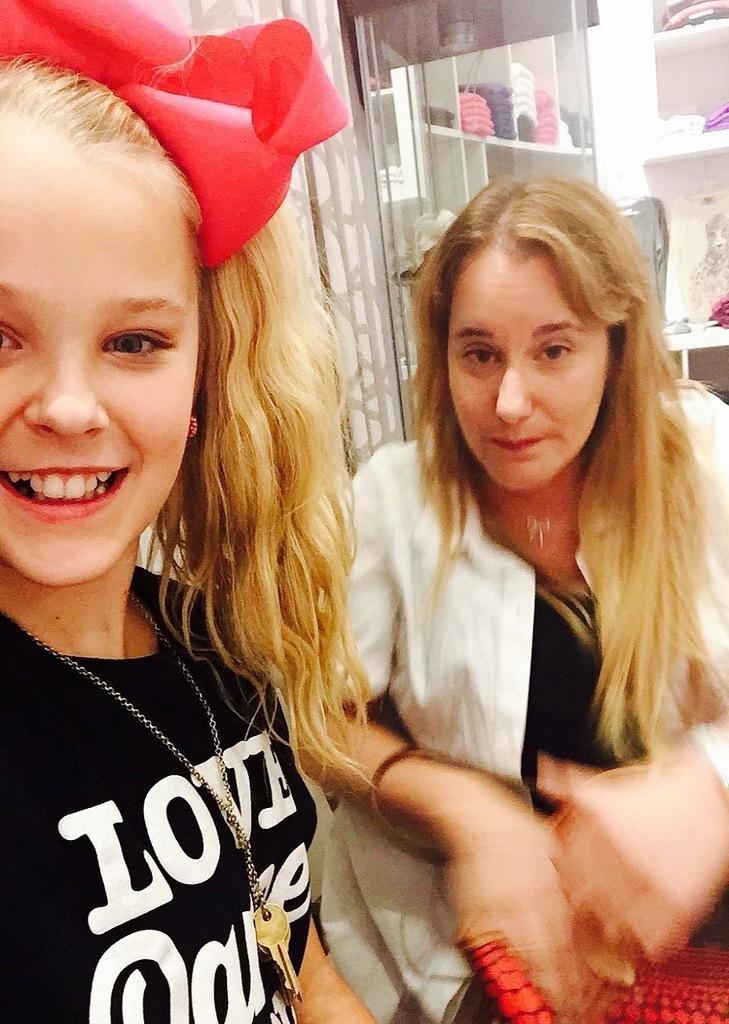Please provide a concise description of this image. Here we can see two persons and she is smiling. In the background we can see glass and there are clothes on the shelf. 